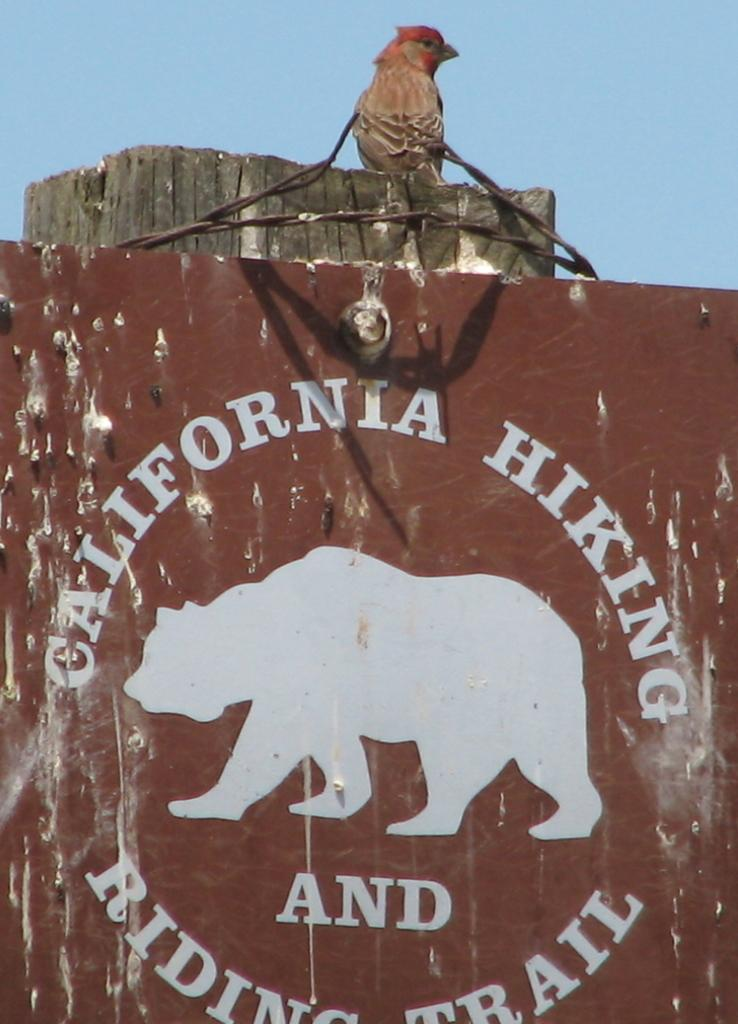What is the main object in the image? There is a board in the image. What is on the board? There is a bird on the board. Can you describe the bird's appearance? The bird is brown and black in color. What can be seen in the background of the image? The sky is blue in the image. How many eggs did the bird lay on the board? There is no indication of eggs in the image; it only shows a bird on the board. 